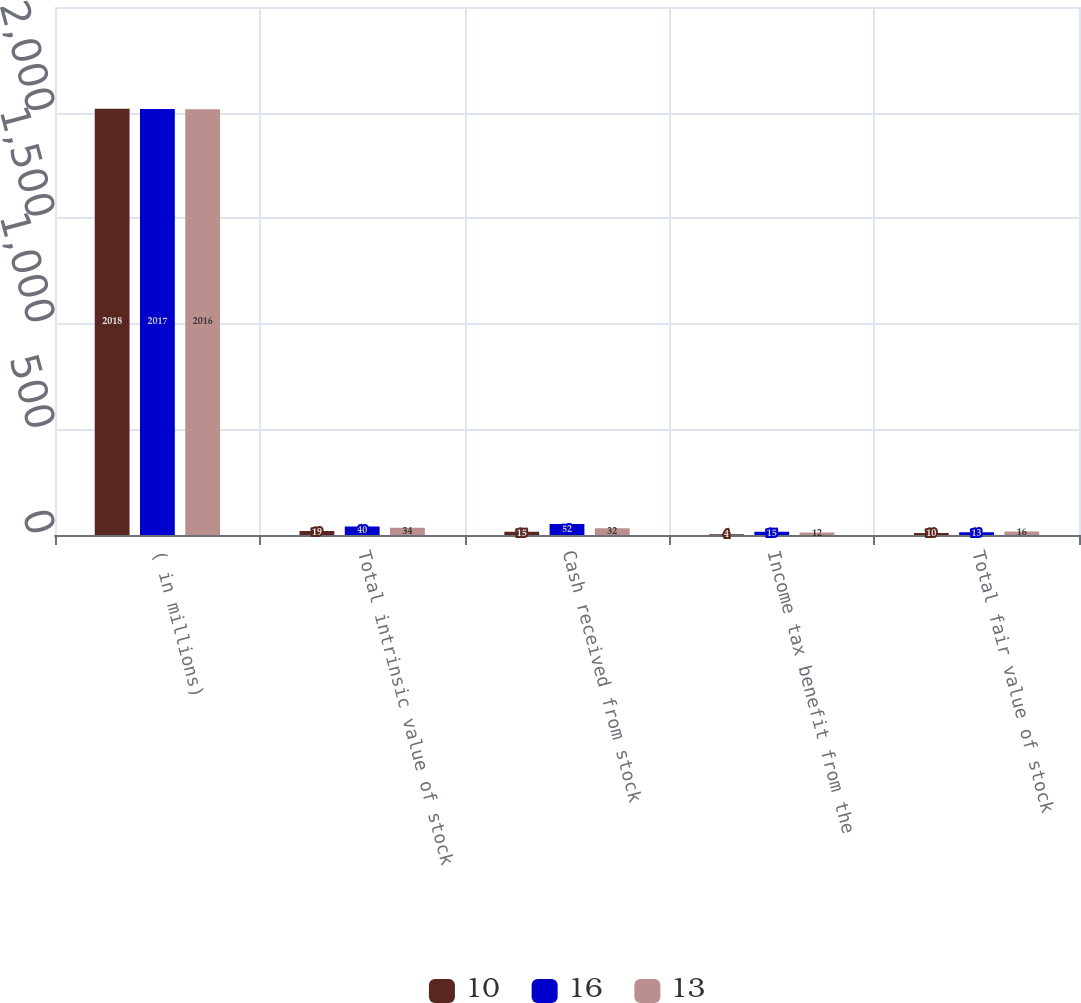<chart> <loc_0><loc_0><loc_500><loc_500><stacked_bar_chart><ecel><fcel>( in millions)<fcel>Total intrinsic value of stock<fcel>Cash received from stock<fcel>Income tax benefit from the<fcel>Total fair value of stock<nl><fcel>10<fcel>2018<fcel>19<fcel>15<fcel>4<fcel>10<nl><fcel>16<fcel>2017<fcel>40<fcel>52<fcel>15<fcel>13<nl><fcel>13<fcel>2016<fcel>34<fcel>32<fcel>12<fcel>16<nl></chart> 